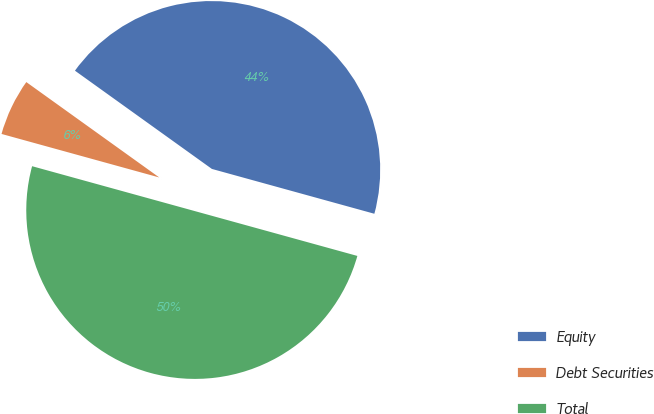Convert chart to OTSL. <chart><loc_0><loc_0><loc_500><loc_500><pie_chart><fcel>Equity<fcel>Debt Securities<fcel>Total<nl><fcel>44.38%<fcel>5.62%<fcel>50.0%<nl></chart> 